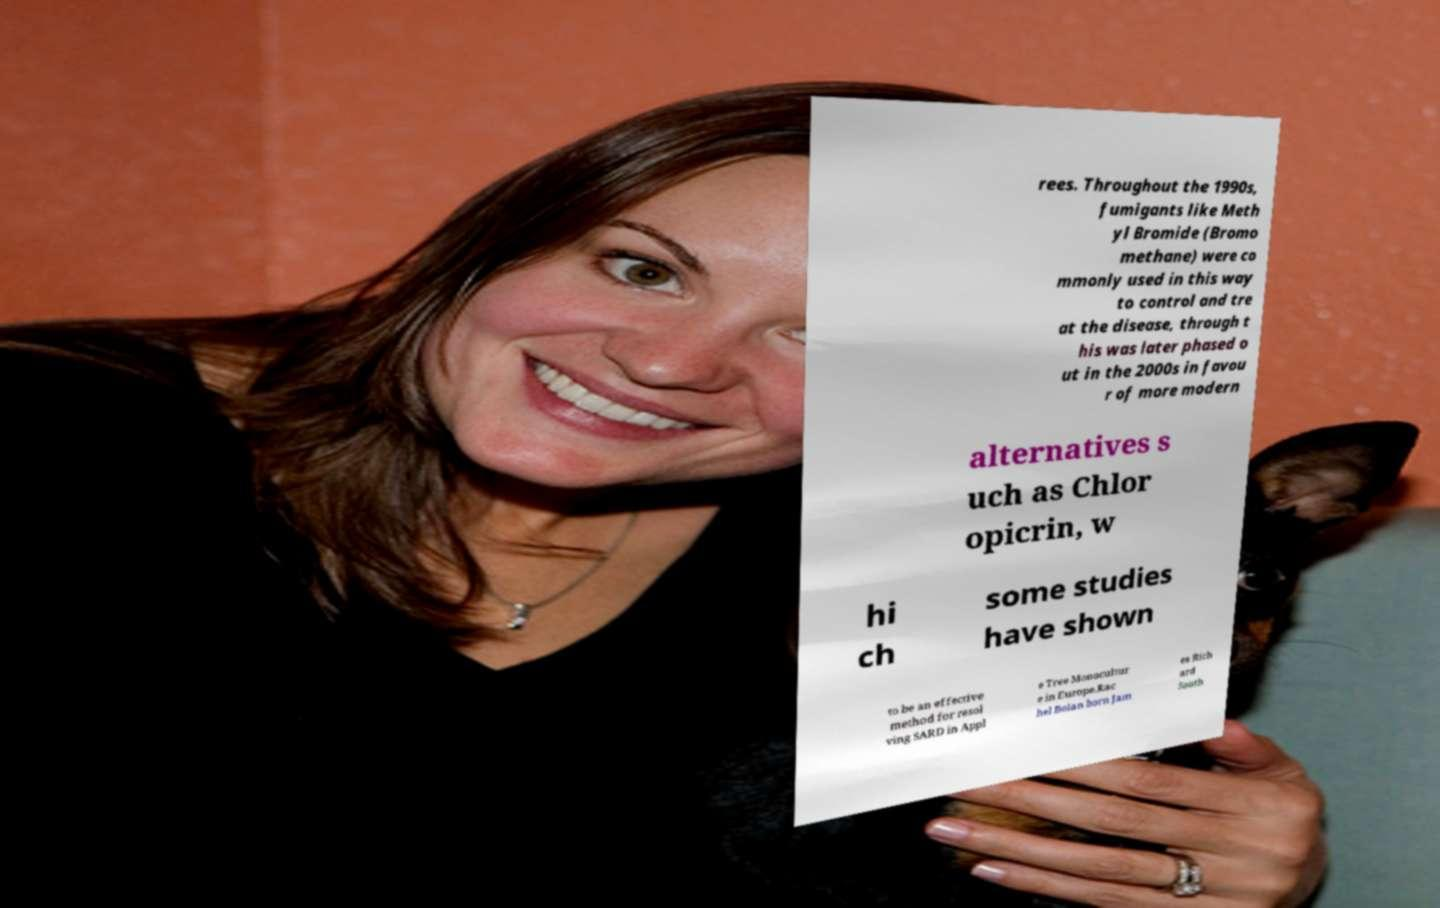Please identify and transcribe the text found in this image. rees. Throughout the 1990s, fumigants like Meth yl Bromide (Bromo methane) were co mmonly used in this way to control and tre at the disease, through t his was later phased o ut in the 2000s in favou r of more modern alternatives s uch as Chlor opicrin, w hi ch some studies have shown to be an effective method for resol ving SARD in Appl e Tree Monocultur e in Europe.Rac hel Bolan born Jam es Rich ard South 